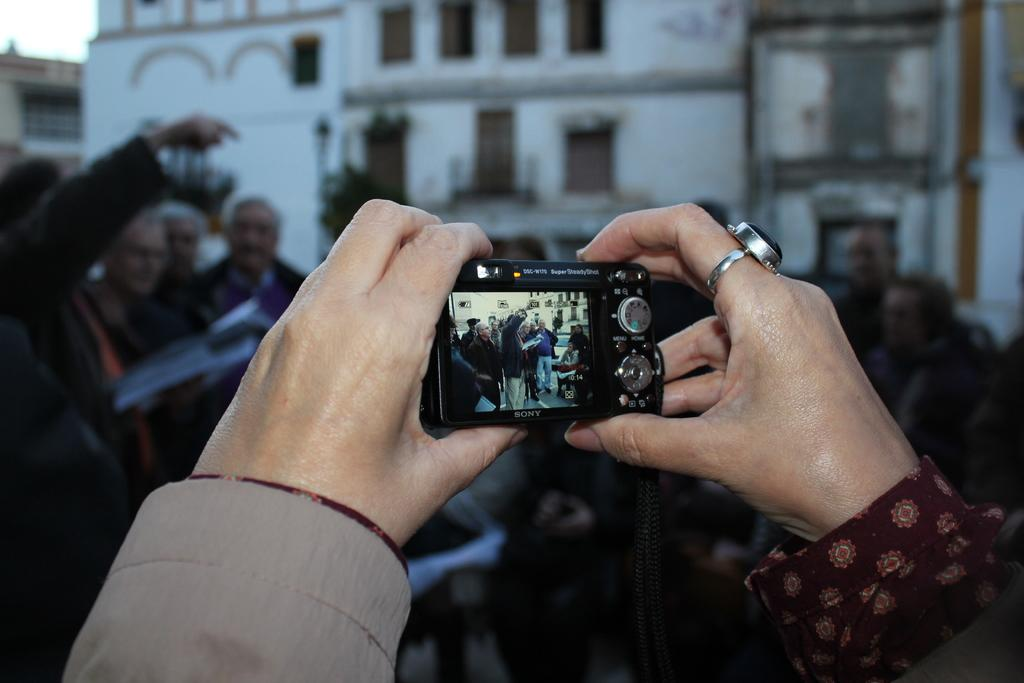How many people are in the center of the image? There are multiple people in the center of the image. What are the people doing in the image? The image does not provide enough information to determine what the people are doing. Can you describe the object being held by two hands in the image? Two hands are holding a camera in the image. What can be seen in the background of the image? There is a building in the background of the image. What is the color of the building in the background? The building is white in color. What statement is being made by the earthquake in the image? There is no earthquake present in the image, so no statement can be made by an earthquake. 